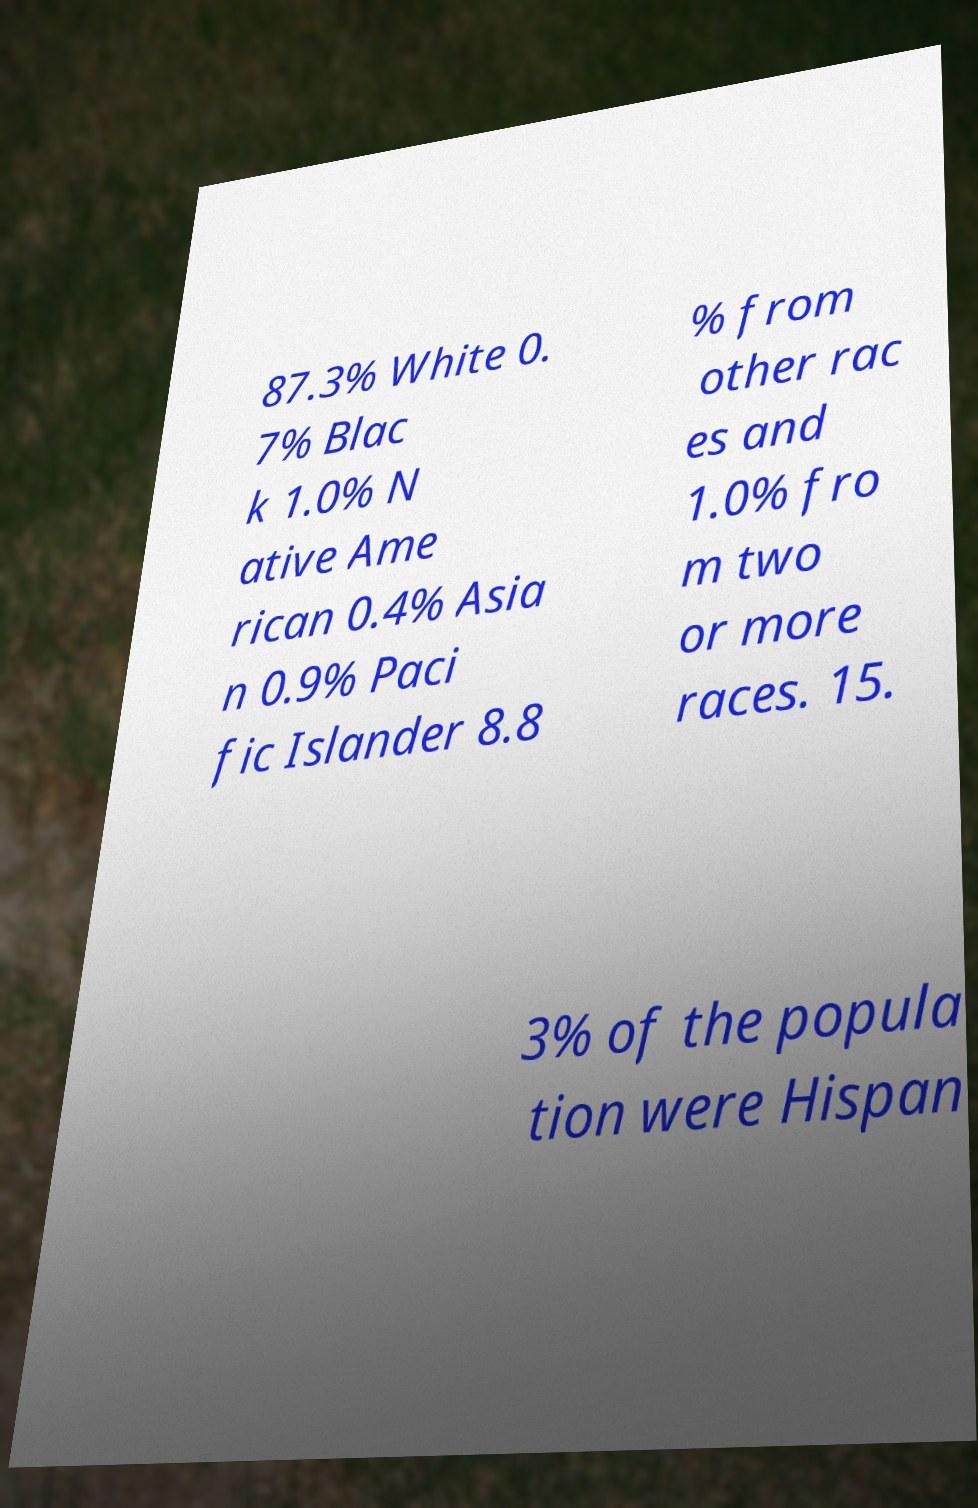There's text embedded in this image that I need extracted. Can you transcribe it verbatim? 87.3% White 0. 7% Blac k 1.0% N ative Ame rican 0.4% Asia n 0.9% Paci fic Islander 8.8 % from other rac es and 1.0% fro m two or more races. 15. 3% of the popula tion were Hispan 